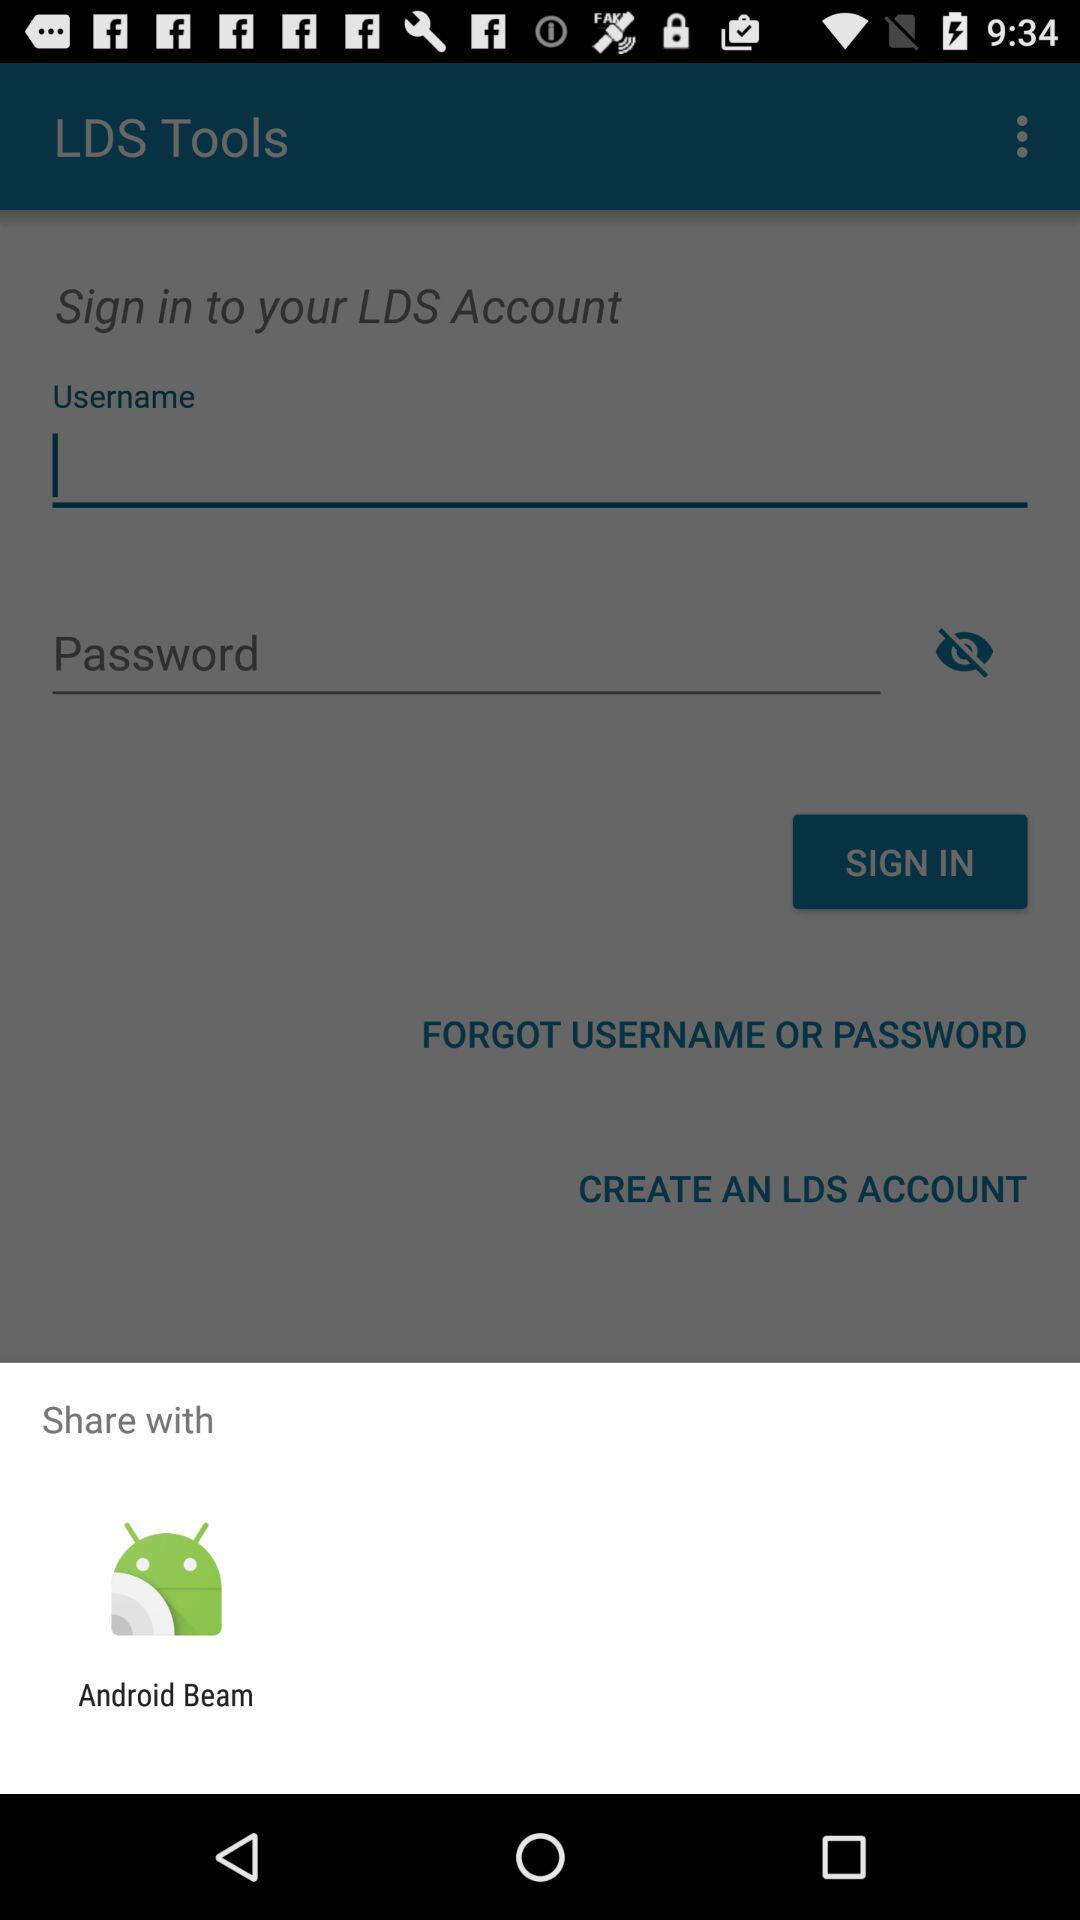Through what application can be shared? You can share it with "Android Beam". 